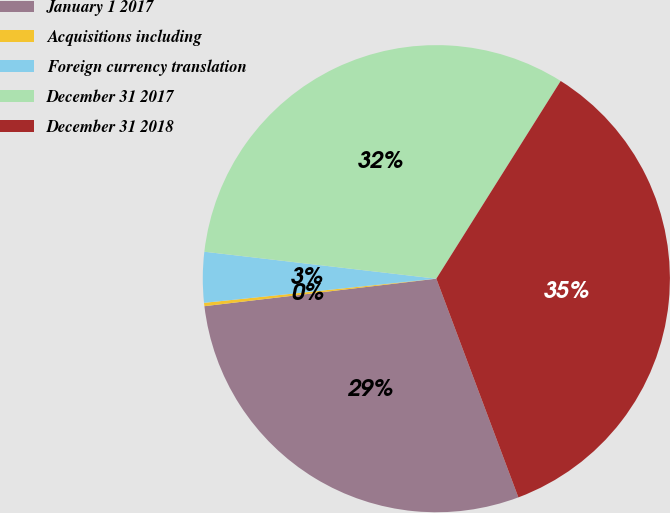<chart> <loc_0><loc_0><loc_500><loc_500><pie_chart><fcel>January 1 2017<fcel>Acquisitions including<fcel>Foreign currency translation<fcel>December 31 2017<fcel>December 31 2018<nl><fcel>28.83%<fcel>0.23%<fcel>3.49%<fcel>32.09%<fcel>35.35%<nl></chart> 